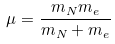<formula> <loc_0><loc_0><loc_500><loc_500>\mu = { \frac { m _ { N } m _ { e } } { m _ { N } + m _ { e } } }</formula> 